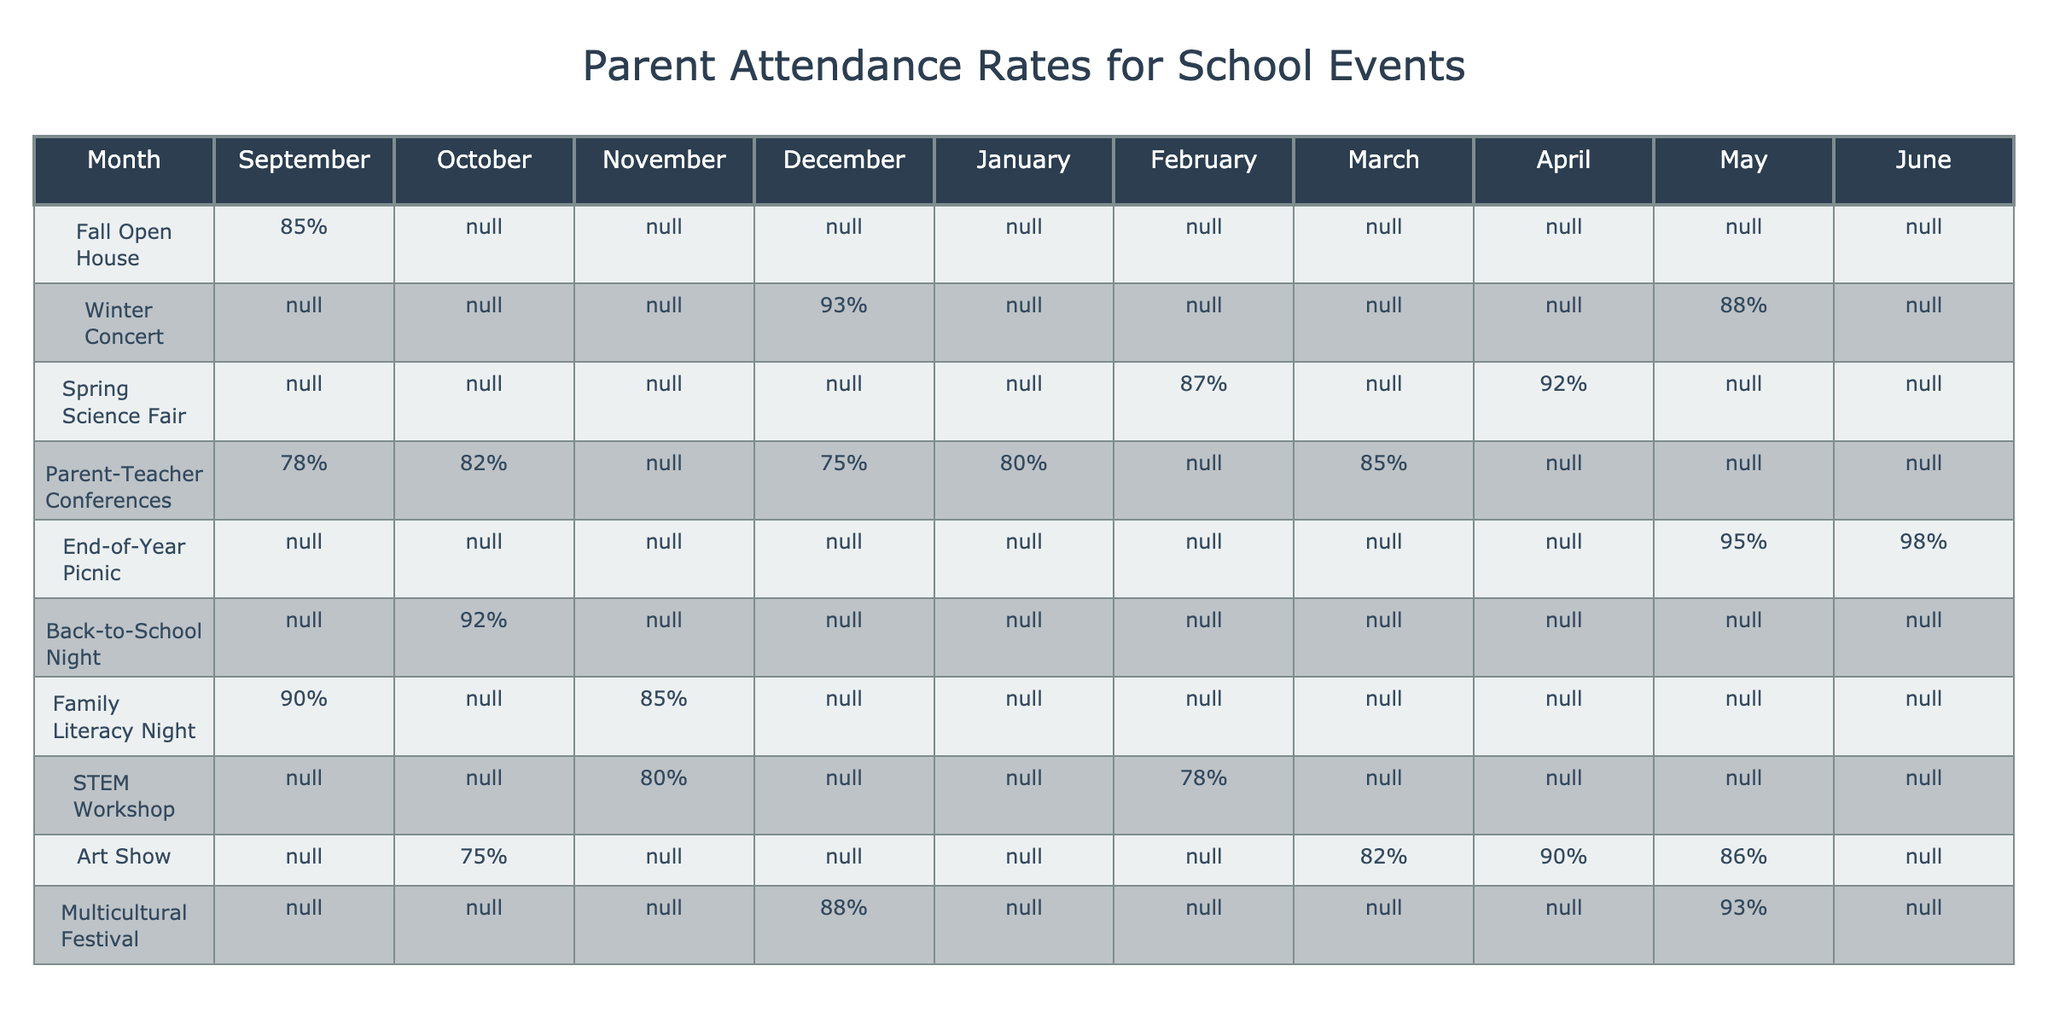What is the attendance rate for the Winter Concert in December? Looking at the table, the attendance rate for the Winter Concert in December is listed directly, which shows a rate of 93%.
Answer: 93% Which event had the highest attendance rate in June? In June, the table shows a 98% attendance rate for the End-of-Year Picnic, which is the highest when compared to other events.
Answer: 98% What is the average attendance rate for the Family Literacy Night? The attendance rates for Family Literacy Night are 90% (September), 75% (October), and 78% (February). Adding these (90 + 75 + 78 = 243) and dividing by the 3 months gives an average of 81%.
Answer: 81% Did attendance for the Spring Science Fair ever reach 90%? Checking the data, the attendance rate for the Spring Science Fair is never shown as 90% or higher, so the answer is no.
Answer: No What was the trend in attendance for STEM Workshop from August to May? The data shows that there is no attendance for the STEM Workshop in the months of August, September, October, and January. In February it’s 78%, in March it’s 82%,  in April it’s 90%, and in May it is 86%. This shows a general increasing trend from February to April, with a slight decline in May.
Answer: Increasing then declining What was the total percentage of attendance for the Parent-Teacher Conferences over the months listed? The attendance rates for Parent-Teacher Conferences are seen in October (82%), November (85%), January (80%), and May (95%). Sum these values (82 + 85 + 80 + 95 = 342), which is the total.
Answer: 342 In which month was attendance for the Multicultural Festival the highest? Reviewing the data for the Multicultural Festival, the highest attendance rate is 93%, which occurs in May.
Answer: May What events had attendance below 80% at least once during the academic year? In the table, attendance rates below 80% occurred for the Parent-Teacher Conferences in January (80%), and for both October (75%) and February (78%) for the Family Literacy Night.
Answer: Parent-Teacher Conferences, Family Literacy Night 